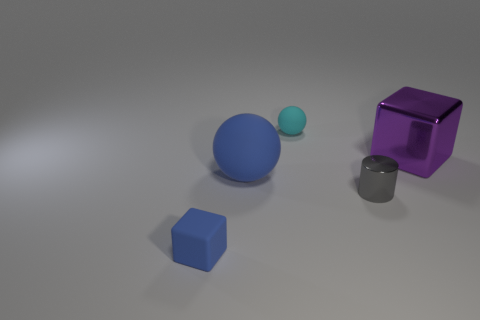Subtract all purple cylinders. Subtract all purple balls. How many cylinders are left? 1 Add 4 blue rubber balls. How many objects exist? 9 Subtract all cylinders. How many objects are left? 4 Subtract 1 gray cylinders. How many objects are left? 4 Subtract all large purple metal things. Subtract all small gray objects. How many objects are left? 3 Add 5 tiny blue matte blocks. How many tiny blue matte blocks are left? 6 Add 1 yellow cylinders. How many yellow cylinders exist? 1 